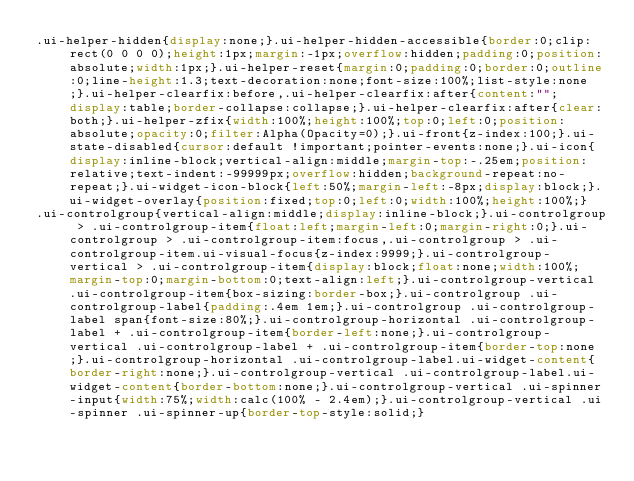Convert code to text. <code><loc_0><loc_0><loc_500><loc_500><_CSS_>.ui-helper-hidden{display:none;}.ui-helper-hidden-accessible{border:0;clip:rect(0 0 0 0);height:1px;margin:-1px;overflow:hidden;padding:0;position:absolute;width:1px;}.ui-helper-reset{margin:0;padding:0;border:0;outline:0;line-height:1.3;text-decoration:none;font-size:100%;list-style:none;}.ui-helper-clearfix:before,.ui-helper-clearfix:after{content:"";display:table;border-collapse:collapse;}.ui-helper-clearfix:after{clear:both;}.ui-helper-zfix{width:100%;height:100%;top:0;left:0;position:absolute;opacity:0;filter:Alpha(Opacity=0);}.ui-front{z-index:100;}.ui-state-disabled{cursor:default !important;pointer-events:none;}.ui-icon{display:inline-block;vertical-align:middle;margin-top:-.25em;position:relative;text-indent:-99999px;overflow:hidden;background-repeat:no-repeat;}.ui-widget-icon-block{left:50%;margin-left:-8px;display:block;}.ui-widget-overlay{position:fixed;top:0;left:0;width:100%;height:100%;}
.ui-controlgroup{vertical-align:middle;display:inline-block;}.ui-controlgroup > .ui-controlgroup-item{float:left;margin-left:0;margin-right:0;}.ui-controlgroup > .ui-controlgroup-item:focus,.ui-controlgroup > .ui-controlgroup-item.ui-visual-focus{z-index:9999;}.ui-controlgroup-vertical > .ui-controlgroup-item{display:block;float:none;width:100%;margin-top:0;margin-bottom:0;text-align:left;}.ui-controlgroup-vertical .ui-controlgroup-item{box-sizing:border-box;}.ui-controlgroup .ui-controlgroup-label{padding:.4em 1em;}.ui-controlgroup .ui-controlgroup-label span{font-size:80%;}.ui-controlgroup-horizontal .ui-controlgroup-label + .ui-controlgroup-item{border-left:none;}.ui-controlgroup-vertical .ui-controlgroup-label + .ui-controlgroup-item{border-top:none;}.ui-controlgroup-horizontal .ui-controlgroup-label.ui-widget-content{border-right:none;}.ui-controlgroup-vertical .ui-controlgroup-label.ui-widget-content{border-bottom:none;}.ui-controlgroup-vertical .ui-spinner-input{width:75%;width:calc(100% - 2.4em);}.ui-controlgroup-vertical .ui-spinner .ui-spinner-up{border-top-style:solid;}</code> 